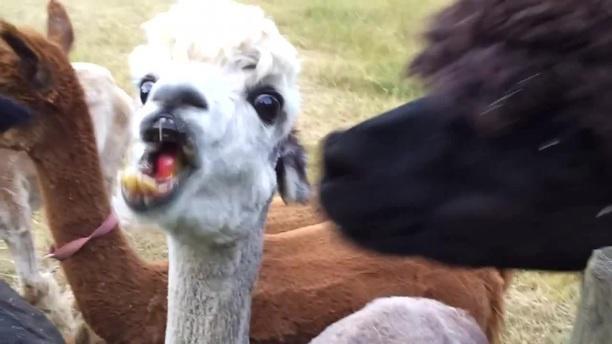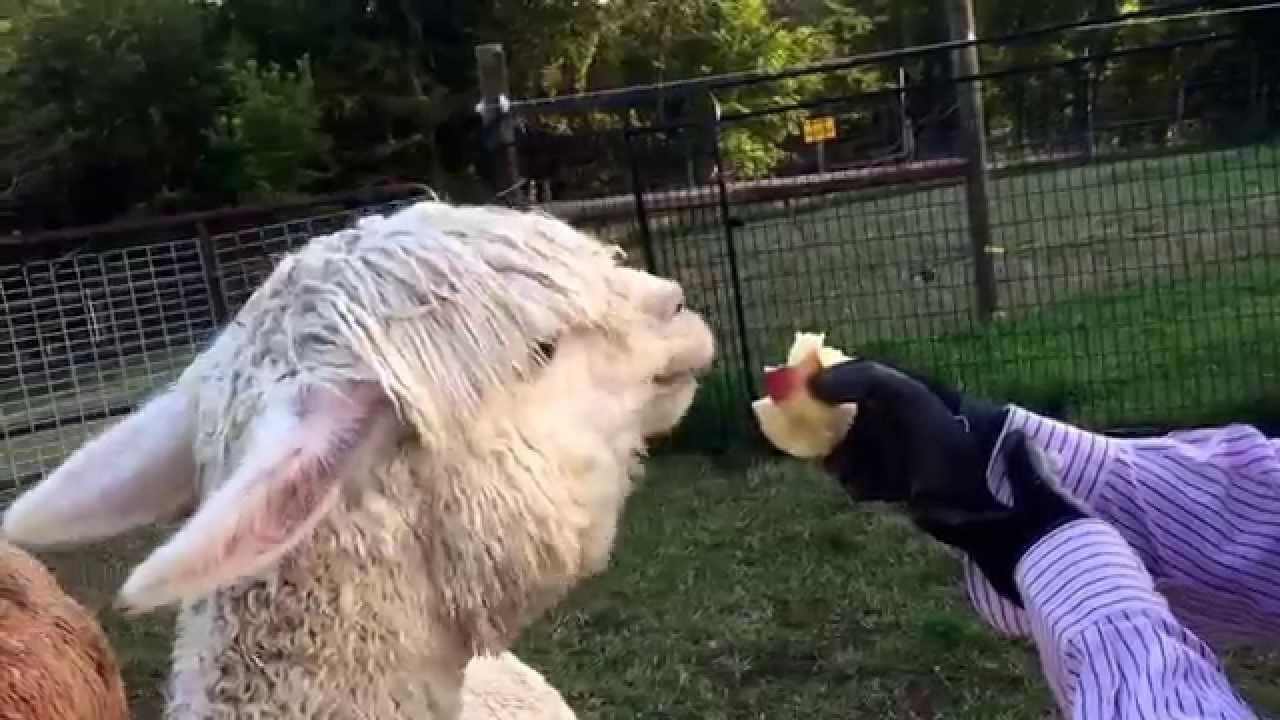The first image is the image on the left, the second image is the image on the right. Considering the images on both sides, is "In the right image, a pair of black-gloved hands are offering an apple to a white llama that is facing rightward." valid? Answer yes or no. Yes. The first image is the image on the left, the second image is the image on the right. Considering the images on both sides, is "A llama is being fed an apple." valid? Answer yes or no. Yes. 